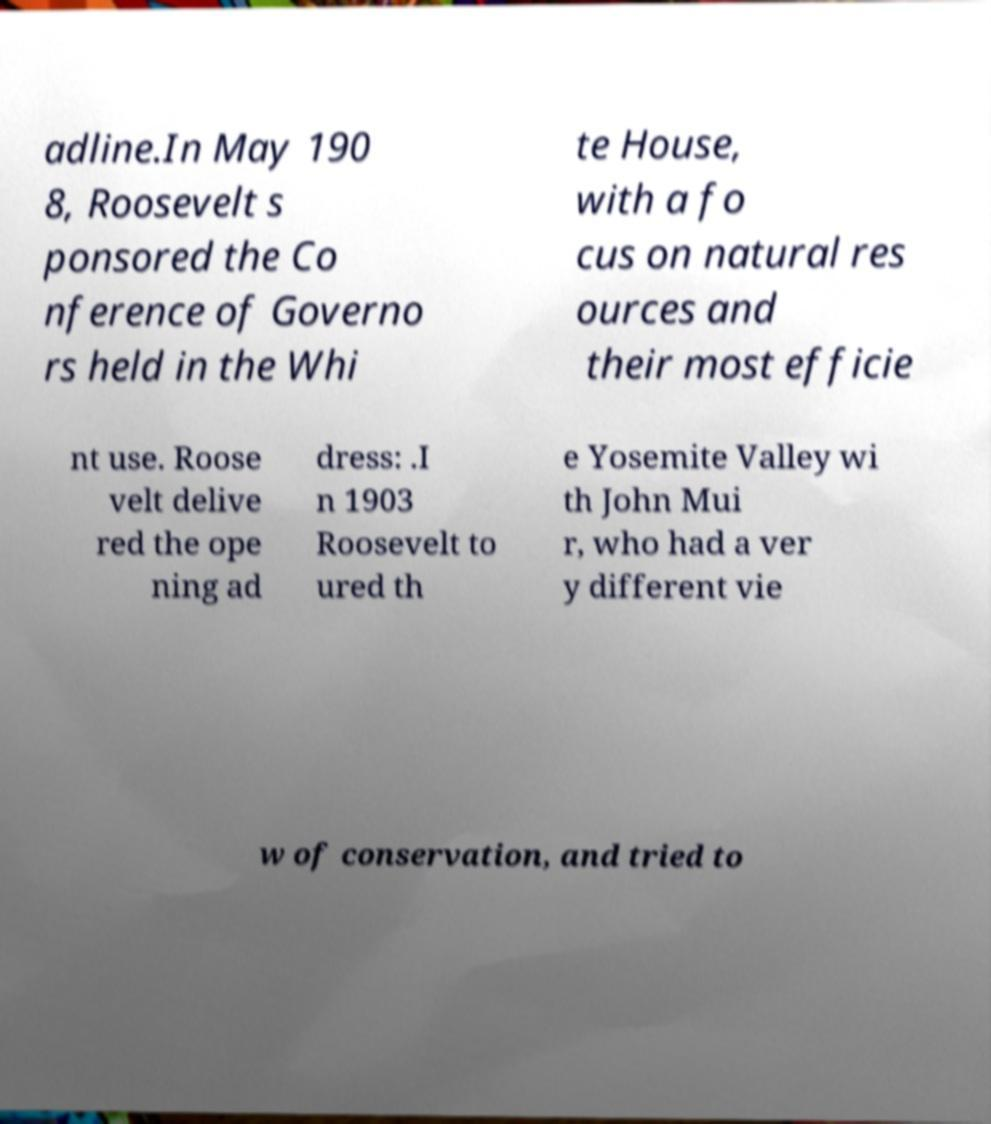Please identify and transcribe the text found in this image. adline.In May 190 8, Roosevelt s ponsored the Co nference of Governo rs held in the Whi te House, with a fo cus on natural res ources and their most efficie nt use. Roose velt delive red the ope ning ad dress: .I n 1903 Roosevelt to ured th e Yosemite Valley wi th John Mui r, who had a ver y different vie w of conservation, and tried to 